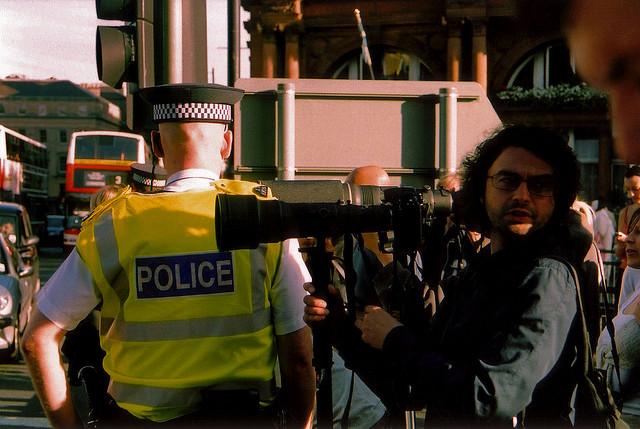What is written on the guy's back?
Be succinct. Police. What event might be taking place here?
Concise answer only. Protest. What's the size of lens on that camera?
Answer briefly. Large. 